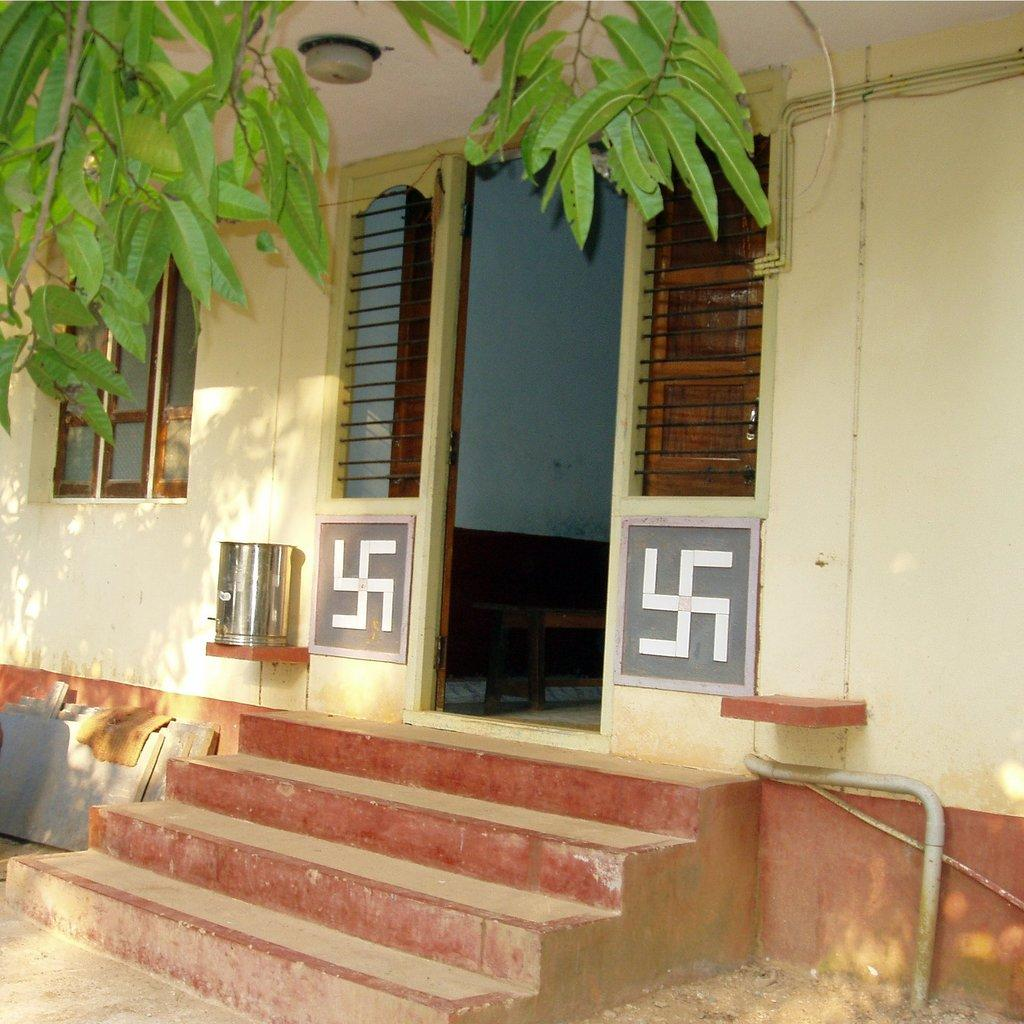What type of structure can be seen in the image? There are stairs and a bench in the image. What material are the iron bars made of? The iron bars are made of iron, as indicated by the fact they are present in the image. What type of vegetation is visible in the image? Green color leaves are visible in the image. What is the steel thing in the image? The fact sheet does not specify the nature of the steel thing, so we cannot provide a definitive answer. What is on the walls in the image? Logos are present on the walls in the image. Is there a cake being served on the bench in the image? There is no cake present in the image. Is there any motion or movement happening in the image? The image is static, so there is no motion or movement depicted. Can you see any steam coming from the iron bars in the image? There is no steam present in the image. 